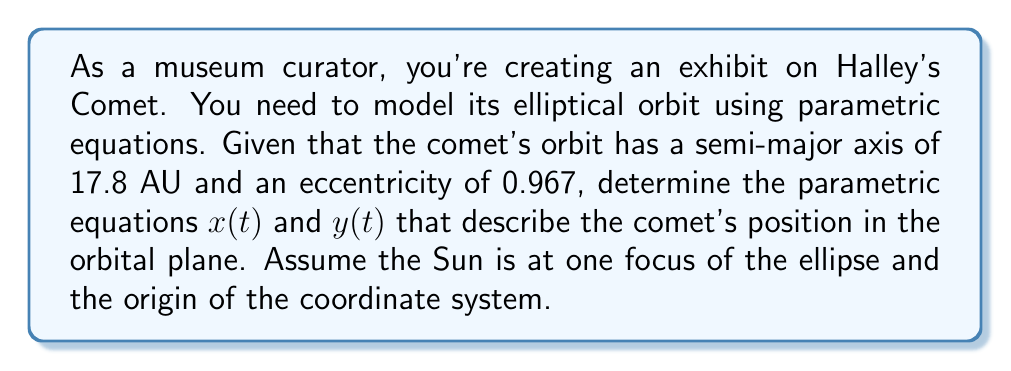Can you answer this question? To model the orbit of Halley's Comet using parametric equations, we'll follow these steps:

1) The general parametric equations for an ellipse centered at the origin are:
   $$x(t) = a \cos(t)$$
   $$y(t) = b \sin(t)$$
   where $a$ is the semi-major axis and $b$ is the semi-minor axis.

2) We're given that $a = 17.8$ AU and the eccentricity $e = 0.967$.

3) To find $b$, we use the relationship between $a$, $b$, and $e$:
   $$e = \sqrt{1 - \frac{b^2}{a^2}}$$

4) Solving for $b$:
   $$0.967 = \sqrt{1 - \frac{b^2}{17.8^2}}$$
   $$0.935089 = 1 - \frac{b^2}{317.44}$$
   $$0.064911 = \frac{b^2}{317.44}$$
   $$b^2 = 20.60559$$
   $$b \approx 4.54$$

5) Now, we need to shift the ellipse so that the Sun is at one focus. The distance from the center to a focus is $ae$:
   $$ae = 17.8 \cdot 0.967 = 17.2126$$

6) We shift the ellipse to the right by this amount:
   $$x(t) = 17.8 \cos(t) + 17.2126$$
   $$y(t) = 4.54 \sin(t)$$

These parametric equations model the orbit of Halley's Comet with the Sun at one focus (0, 0).
Answer: The parametric equations modeling Halley's Comet's orbit are:
$$x(t) = 17.8 \cos(t) + 17.2126$$
$$y(t) = 4.54 \sin(t)$$
where $t$ is the parameter (0 ≤ t < 2π) and distances are in AU. 